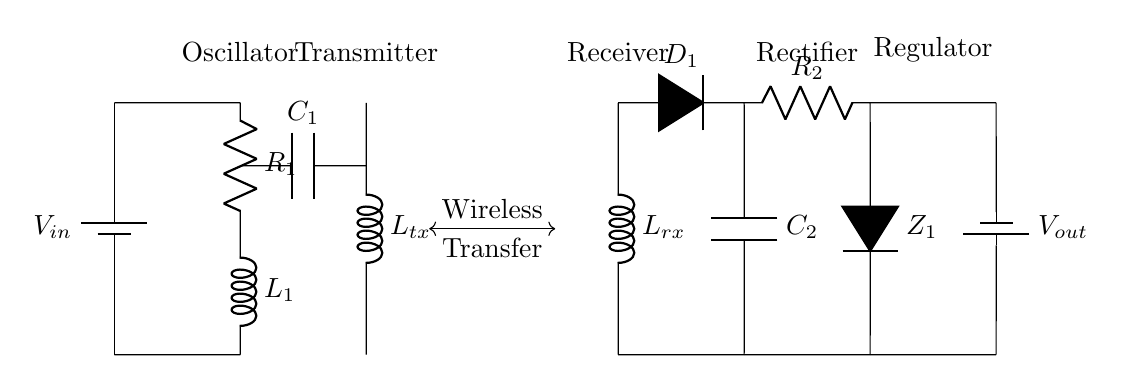What type of circuit is this? This circuit is a wireless charging circuit. It includes components for oscillation, transmission, and reception of power wirelessly.
Answer: Wireless charging What is the purpose of L_tx? L_tx, or the transmitter coil, generates the magnetic field required for wireless energy transfer by creating an alternating magnetic field when current flows through it.
Answer: Generate magnetic field How many capacitors are present in the circuit? There are two capacitors in the circuit: one labeled C1 and another labeled C2, both used in the charging and rectification process.
Answer: Two What component converts AC to DC? D1, the diode, is the component that rectifies alternating current (AC) from the transmitter coil into direct current (DC) for the wearable device.
Answer: D1 What does C1 do in this circuit? C1 is used for filtering and stabilizing the oscillation, ensuring smooth operation of the oscillator circuit.
Answer: Filtering and stabilizing Which element controls the output voltage? R2 acts as a voltage regulator, controlling and stabilizing the voltage output to the wearable device ensuring it receives the correct voltage.
Answer: R2 